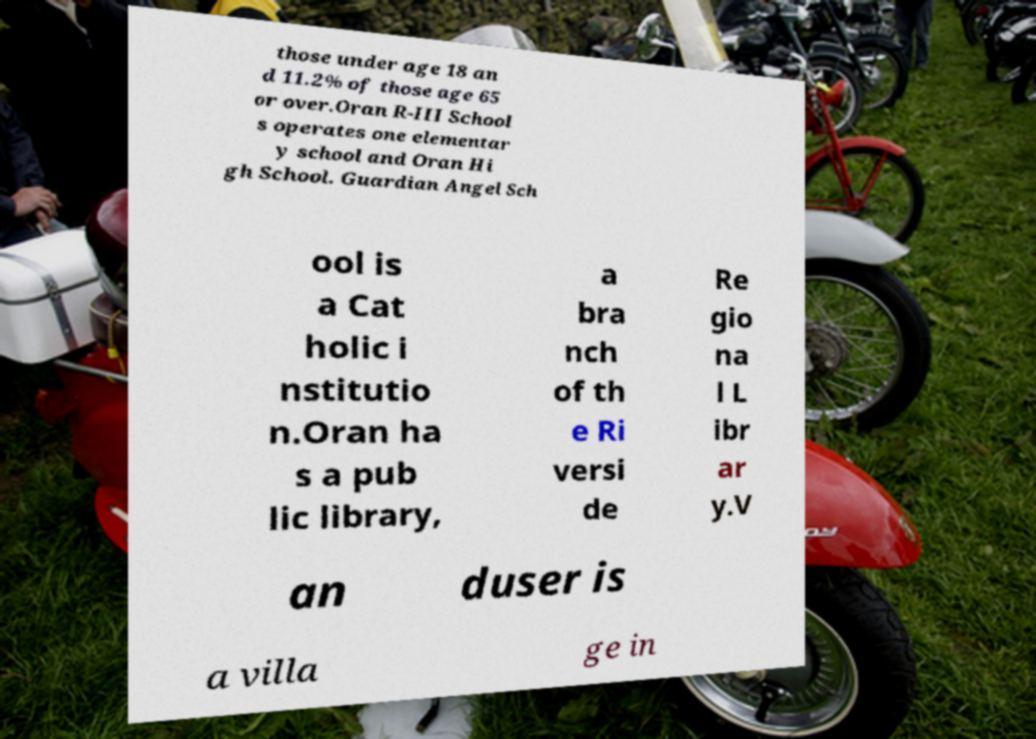What messages or text are displayed in this image? I need them in a readable, typed format. those under age 18 an d 11.2% of those age 65 or over.Oran R-III School s operates one elementar y school and Oran Hi gh School. Guardian Angel Sch ool is a Cat holic i nstitutio n.Oran ha s a pub lic library, a bra nch of th e Ri versi de Re gio na l L ibr ar y.V an duser is a villa ge in 